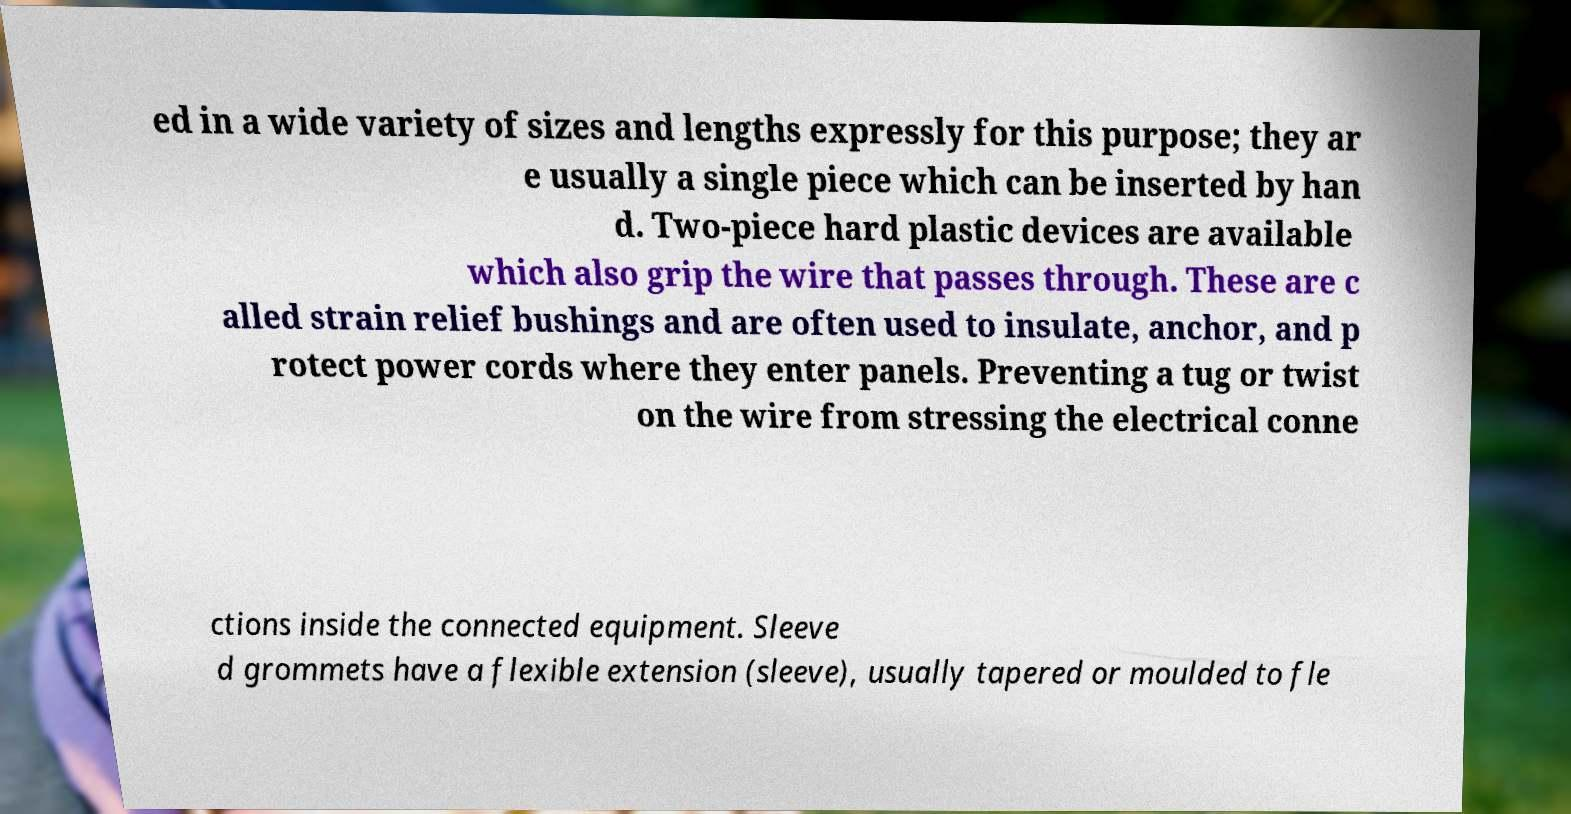For documentation purposes, I need the text within this image transcribed. Could you provide that? ed in a wide variety of sizes and lengths expressly for this purpose; they ar e usually a single piece which can be inserted by han d. Two-piece hard plastic devices are available which also grip the wire that passes through. These are c alled strain relief bushings and are often used to insulate, anchor, and p rotect power cords where they enter panels. Preventing a tug or twist on the wire from stressing the electrical conne ctions inside the connected equipment. Sleeve d grommets have a flexible extension (sleeve), usually tapered or moulded to fle 